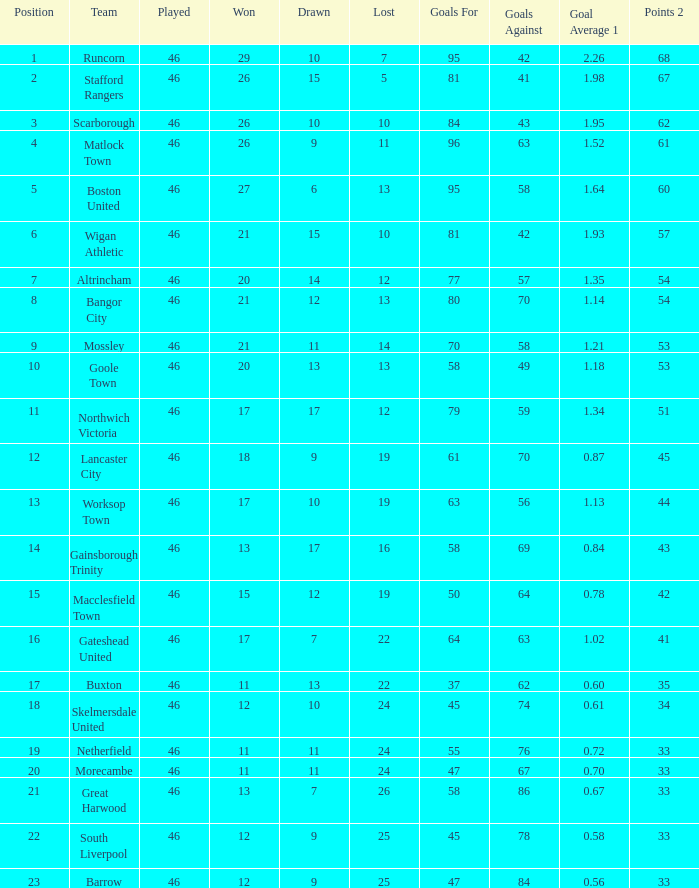Provide a list of all setbacks with an average goal score of 1.21. 14.0. 